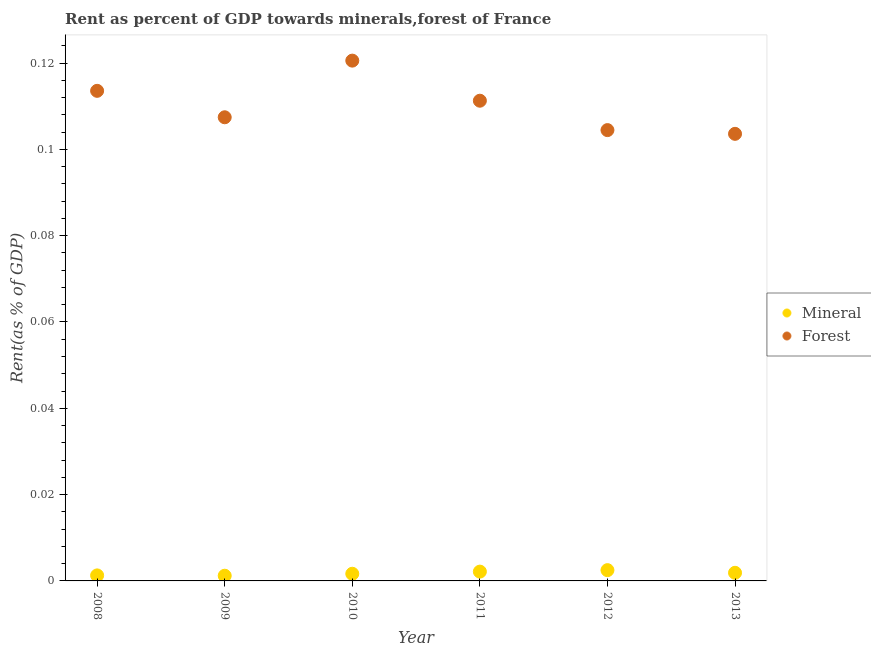How many different coloured dotlines are there?
Keep it short and to the point. 2. What is the forest rent in 2011?
Your answer should be compact. 0.11. Across all years, what is the maximum mineral rent?
Ensure brevity in your answer.  0. Across all years, what is the minimum forest rent?
Keep it short and to the point. 0.1. In which year was the forest rent maximum?
Offer a terse response. 2010. What is the total mineral rent in the graph?
Your answer should be very brief. 0.01. What is the difference between the mineral rent in 2008 and that in 2009?
Ensure brevity in your answer.  7.489023253651997e-5. What is the difference between the forest rent in 2011 and the mineral rent in 2008?
Provide a succinct answer. 0.11. What is the average mineral rent per year?
Provide a short and direct response. 0. In the year 2008, what is the difference between the forest rent and mineral rent?
Offer a very short reply. 0.11. In how many years, is the forest rent greater than 0.056 %?
Keep it short and to the point. 6. What is the ratio of the mineral rent in 2009 to that in 2011?
Offer a very short reply. 0.56. Is the difference between the mineral rent in 2009 and 2012 greater than the difference between the forest rent in 2009 and 2012?
Your answer should be compact. No. What is the difference between the highest and the second highest mineral rent?
Your answer should be very brief. 0. What is the difference between the highest and the lowest forest rent?
Provide a short and direct response. 0.02. In how many years, is the mineral rent greater than the average mineral rent taken over all years?
Make the answer very short. 3. Is the mineral rent strictly less than the forest rent over the years?
Your answer should be very brief. Yes. How many dotlines are there?
Keep it short and to the point. 2. How many years are there in the graph?
Make the answer very short. 6. What is the difference between two consecutive major ticks on the Y-axis?
Keep it short and to the point. 0.02. Are the values on the major ticks of Y-axis written in scientific E-notation?
Provide a short and direct response. No. Where does the legend appear in the graph?
Provide a succinct answer. Center right. How many legend labels are there?
Your answer should be compact. 2. How are the legend labels stacked?
Provide a succinct answer. Vertical. What is the title of the graph?
Provide a succinct answer. Rent as percent of GDP towards minerals,forest of France. What is the label or title of the Y-axis?
Provide a short and direct response. Rent(as % of GDP). What is the Rent(as % of GDP) of Mineral in 2008?
Offer a terse response. 0. What is the Rent(as % of GDP) of Forest in 2008?
Provide a succinct answer. 0.11. What is the Rent(as % of GDP) in Mineral in 2009?
Your answer should be compact. 0. What is the Rent(as % of GDP) of Forest in 2009?
Make the answer very short. 0.11. What is the Rent(as % of GDP) in Mineral in 2010?
Keep it short and to the point. 0. What is the Rent(as % of GDP) in Forest in 2010?
Ensure brevity in your answer.  0.12. What is the Rent(as % of GDP) of Mineral in 2011?
Your answer should be very brief. 0. What is the Rent(as % of GDP) in Forest in 2011?
Provide a short and direct response. 0.11. What is the Rent(as % of GDP) of Mineral in 2012?
Offer a terse response. 0. What is the Rent(as % of GDP) in Forest in 2012?
Give a very brief answer. 0.1. What is the Rent(as % of GDP) of Mineral in 2013?
Keep it short and to the point. 0. What is the Rent(as % of GDP) in Forest in 2013?
Keep it short and to the point. 0.1. Across all years, what is the maximum Rent(as % of GDP) in Mineral?
Keep it short and to the point. 0. Across all years, what is the maximum Rent(as % of GDP) of Forest?
Your answer should be compact. 0.12. Across all years, what is the minimum Rent(as % of GDP) in Mineral?
Your answer should be very brief. 0. Across all years, what is the minimum Rent(as % of GDP) in Forest?
Keep it short and to the point. 0.1. What is the total Rent(as % of GDP) of Mineral in the graph?
Provide a succinct answer. 0.01. What is the total Rent(as % of GDP) in Forest in the graph?
Offer a very short reply. 0.66. What is the difference between the Rent(as % of GDP) of Forest in 2008 and that in 2009?
Make the answer very short. 0.01. What is the difference between the Rent(as % of GDP) of Mineral in 2008 and that in 2010?
Offer a terse response. -0. What is the difference between the Rent(as % of GDP) in Forest in 2008 and that in 2010?
Your answer should be very brief. -0.01. What is the difference between the Rent(as % of GDP) of Mineral in 2008 and that in 2011?
Your response must be concise. -0. What is the difference between the Rent(as % of GDP) of Forest in 2008 and that in 2011?
Provide a succinct answer. 0. What is the difference between the Rent(as % of GDP) of Mineral in 2008 and that in 2012?
Offer a terse response. -0. What is the difference between the Rent(as % of GDP) in Forest in 2008 and that in 2012?
Ensure brevity in your answer.  0.01. What is the difference between the Rent(as % of GDP) of Mineral in 2008 and that in 2013?
Provide a short and direct response. -0. What is the difference between the Rent(as % of GDP) in Mineral in 2009 and that in 2010?
Your answer should be compact. -0. What is the difference between the Rent(as % of GDP) of Forest in 2009 and that in 2010?
Provide a short and direct response. -0.01. What is the difference between the Rent(as % of GDP) of Mineral in 2009 and that in 2011?
Your response must be concise. -0. What is the difference between the Rent(as % of GDP) of Forest in 2009 and that in 2011?
Offer a very short reply. -0. What is the difference between the Rent(as % of GDP) in Mineral in 2009 and that in 2012?
Give a very brief answer. -0. What is the difference between the Rent(as % of GDP) in Forest in 2009 and that in 2012?
Your answer should be very brief. 0. What is the difference between the Rent(as % of GDP) in Mineral in 2009 and that in 2013?
Provide a succinct answer. -0. What is the difference between the Rent(as % of GDP) in Forest in 2009 and that in 2013?
Make the answer very short. 0. What is the difference between the Rent(as % of GDP) of Mineral in 2010 and that in 2011?
Give a very brief answer. -0. What is the difference between the Rent(as % of GDP) in Forest in 2010 and that in 2011?
Your answer should be very brief. 0.01. What is the difference between the Rent(as % of GDP) in Mineral in 2010 and that in 2012?
Ensure brevity in your answer.  -0. What is the difference between the Rent(as % of GDP) in Forest in 2010 and that in 2012?
Keep it short and to the point. 0.02. What is the difference between the Rent(as % of GDP) of Mineral in 2010 and that in 2013?
Your answer should be very brief. -0. What is the difference between the Rent(as % of GDP) of Forest in 2010 and that in 2013?
Your answer should be compact. 0.02. What is the difference between the Rent(as % of GDP) of Mineral in 2011 and that in 2012?
Offer a very short reply. -0. What is the difference between the Rent(as % of GDP) of Forest in 2011 and that in 2012?
Offer a terse response. 0.01. What is the difference between the Rent(as % of GDP) of Forest in 2011 and that in 2013?
Give a very brief answer. 0.01. What is the difference between the Rent(as % of GDP) of Mineral in 2012 and that in 2013?
Provide a succinct answer. 0. What is the difference between the Rent(as % of GDP) of Forest in 2012 and that in 2013?
Ensure brevity in your answer.  0. What is the difference between the Rent(as % of GDP) in Mineral in 2008 and the Rent(as % of GDP) in Forest in 2009?
Keep it short and to the point. -0.11. What is the difference between the Rent(as % of GDP) in Mineral in 2008 and the Rent(as % of GDP) in Forest in 2010?
Give a very brief answer. -0.12. What is the difference between the Rent(as % of GDP) of Mineral in 2008 and the Rent(as % of GDP) of Forest in 2011?
Offer a very short reply. -0.11. What is the difference between the Rent(as % of GDP) in Mineral in 2008 and the Rent(as % of GDP) in Forest in 2012?
Ensure brevity in your answer.  -0.1. What is the difference between the Rent(as % of GDP) in Mineral in 2008 and the Rent(as % of GDP) in Forest in 2013?
Offer a terse response. -0.1. What is the difference between the Rent(as % of GDP) of Mineral in 2009 and the Rent(as % of GDP) of Forest in 2010?
Your answer should be very brief. -0.12. What is the difference between the Rent(as % of GDP) in Mineral in 2009 and the Rent(as % of GDP) in Forest in 2011?
Your answer should be compact. -0.11. What is the difference between the Rent(as % of GDP) in Mineral in 2009 and the Rent(as % of GDP) in Forest in 2012?
Make the answer very short. -0.1. What is the difference between the Rent(as % of GDP) in Mineral in 2009 and the Rent(as % of GDP) in Forest in 2013?
Provide a succinct answer. -0.1. What is the difference between the Rent(as % of GDP) of Mineral in 2010 and the Rent(as % of GDP) of Forest in 2011?
Make the answer very short. -0.11. What is the difference between the Rent(as % of GDP) in Mineral in 2010 and the Rent(as % of GDP) in Forest in 2012?
Keep it short and to the point. -0.1. What is the difference between the Rent(as % of GDP) of Mineral in 2010 and the Rent(as % of GDP) of Forest in 2013?
Make the answer very short. -0.1. What is the difference between the Rent(as % of GDP) of Mineral in 2011 and the Rent(as % of GDP) of Forest in 2012?
Provide a succinct answer. -0.1. What is the difference between the Rent(as % of GDP) in Mineral in 2011 and the Rent(as % of GDP) in Forest in 2013?
Offer a very short reply. -0.1. What is the difference between the Rent(as % of GDP) of Mineral in 2012 and the Rent(as % of GDP) of Forest in 2013?
Your answer should be compact. -0.1. What is the average Rent(as % of GDP) of Mineral per year?
Ensure brevity in your answer.  0. What is the average Rent(as % of GDP) in Forest per year?
Your answer should be compact. 0.11. In the year 2008, what is the difference between the Rent(as % of GDP) of Mineral and Rent(as % of GDP) of Forest?
Offer a very short reply. -0.11. In the year 2009, what is the difference between the Rent(as % of GDP) in Mineral and Rent(as % of GDP) in Forest?
Your answer should be compact. -0.11. In the year 2010, what is the difference between the Rent(as % of GDP) in Mineral and Rent(as % of GDP) in Forest?
Ensure brevity in your answer.  -0.12. In the year 2011, what is the difference between the Rent(as % of GDP) of Mineral and Rent(as % of GDP) of Forest?
Offer a very short reply. -0.11. In the year 2012, what is the difference between the Rent(as % of GDP) in Mineral and Rent(as % of GDP) in Forest?
Provide a succinct answer. -0.1. In the year 2013, what is the difference between the Rent(as % of GDP) in Mineral and Rent(as % of GDP) in Forest?
Offer a very short reply. -0.1. What is the ratio of the Rent(as % of GDP) in Mineral in 2008 to that in 2009?
Provide a short and direct response. 1.06. What is the ratio of the Rent(as % of GDP) in Forest in 2008 to that in 2009?
Offer a very short reply. 1.06. What is the ratio of the Rent(as % of GDP) in Mineral in 2008 to that in 2010?
Offer a very short reply. 0.77. What is the ratio of the Rent(as % of GDP) in Forest in 2008 to that in 2010?
Your response must be concise. 0.94. What is the ratio of the Rent(as % of GDP) of Mineral in 2008 to that in 2011?
Offer a very short reply. 0.59. What is the ratio of the Rent(as % of GDP) of Forest in 2008 to that in 2011?
Your answer should be very brief. 1.02. What is the ratio of the Rent(as % of GDP) in Mineral in 2008 to that in 2012?
Offer a terse response. 0.51. What is the ratio of the Rent(as % of GDP) in Forest in 2008 to that in 2012?
Your answer should be compact. 1.09. What is the ratio of the Rent(as % of GDP) of Mineral in 2008 to that in 2013?
Provide a short and direct response. 0.68. What is the ratio of the Rent(as % of GDP) of Forest in 2008 to that in 2013?
Offer a terse response. 1.1. What is the ratio of the Rent(as % of GDP) in Mineral in 2009 to that in 2010?
Ensure brevity in your answer.  0.73. What is the ratio of the Rent(as % of GDP) of Forest in 2009 to that in 2010?
Offer a terse response. 0.89. What is the ratio of the Rent(as % of GDP) of Mineral in 2009 to that in 2011?
Keep it short and to the point. 0.56. What is the ratio of the Rent(as % of GDP) in Forest in 2009 to that in 2011?
Your response must be concise. 0.97. What is the ratio of the Rent(as % of GDP) of Mineral in 2009 to that in 2012?
Your response must be concise. 0.48. What is the ratio of the Rent(as % of GDP) in Forest in 2009 to that in 2012?
Offer a very short reply. 1.03. What is the ratio of the Rent(as % of GDP) of Mineral in 2009 to that in 2013?
Your answer should be very brief. 0.64. What is the ratio of the Rent(as % of GDP) in Forest in 2009 to that in 2013?
Offer a very short reply. 1.04. What is the ratio of the Rent(as % of GDP) in Mineral in 2010 to that in 2011?
Give a very brief answer. 0.77. What is the ratio of the Rent(as % of GDP) of Forest in 2010 to that in 2011?
Offer a very short reply. 1.08. What is the ratio of the Rent(as % of GDP) in Mineral in 2010 to that in 2012?
Offer a very short reply. 0.67. What is the ratio of the Rent(as % of GDP) in Forest in 2010 to that in 2012?
Give a very brief answer. 1.15. What is the ratio of the Rent(as % of GDP) in Mineral in 2010 to that in 2013?
Provide a succinct answer. 0.88. What is the ratio of the Rent(as % of GDP) in Forest in 2010 to that in 2013?
Your answer should be very brief. 1.16. What is the ratio of the Rent(as % of GDP) of Mineral in 2011 to that in 2012?
Provide a succinct answer. 0.86. What is the ratio of the Rent(as % of GDP) in Forest in 2011 to that in 2012?
Your answer should be very brief. 1.07. What is the ratio of the Rent(as % of GDP) in Mineral in 2011 to that in 2013?
Keep it short and to the point. 1.15. What is the ratio of the Rent(as % of GDP) of Forest in 2011 to that in 2013?
Keep it short and to the point. 1.07. What is the ratio of the Rent(as % of GDP) of Mineral in 2012 to that in 2013?
Offer a very short reply. 1.33. What is the ratio of the Rent(as % of GDP) of Forest in 2012 to that in 2013?
Provide a succinct answer. 1.01. What is the difference between the highest and the second highest Rent(as % of GDP) of Forest?
Make the answer very short. 0.01. What is the difference between the highest and the lowest Rent(as % of GDP) in Mineral?
Offer a very short reply. 0. What is the difference between the highest and the lowest Rent(as % of GDP) of Forest?
Offer a terse response. 0.02. 